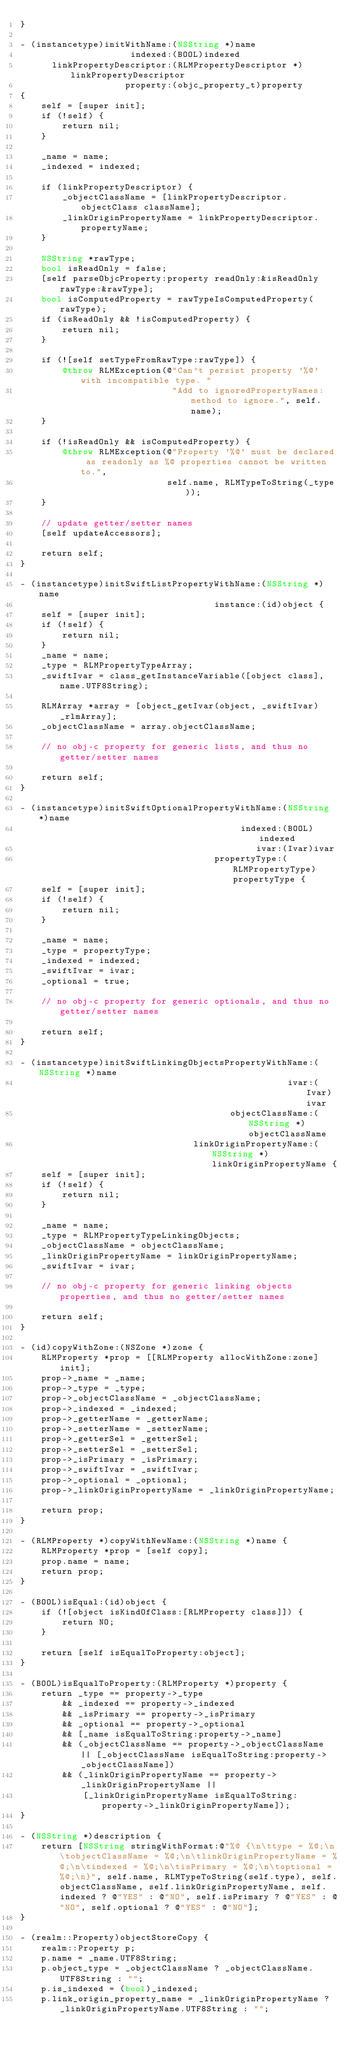Convert code to text. <code><loc_0><loc_0><loc_500><loc_500><_ObjectiveC_>}

- (instancetype)initWithName:(NSString *)name
                     indexed:(BOOL)indexed
      linkPropertyDescriptor:(RLMPropertyDescriptor *)linkPropertyDescriptor
                    property:(objc_property_t)property
{
    self = [super init];
    if (!self) {
        return nil;
    }

    _name = name;
    _indexed = indexed;

    if (linkPropertyDescriptor) {
        _objectClassName = [linkPropertyDescriptor.objectClass className];
        _linkOriginPropertyName = linkPropertyDescriptor.propertyName;
    }

    NSString *rawType;
    bool isReadOnly = false;
    [self parseObjcProperty:property readOnly:&isReadOnly rawType:&rawType];
    bool isComputedProperty = rawTypeIsComputedProperty(rawType);
    if (isReadOnly && !isComputedProperty) {
        return nil;
    }

    if (![self setTypeFromRawType:rawType]) {
        @throw RLMException(@"Can't persist property '%@' with incompatible type. "
                             "Add to ignoredPropertyNames: method to ignore.", self.name);
    }

    if (!isReadOnly && isComputedProperty) {
        @throw RLMException(@"Property '%@' must be declared as readonly as %@ properties cannot be written to.",
                            self.name, RLMTypeToString(_type));
    }

    // update getter/setter names
    [self updateAccessors];

    return self;
}

- (instancetype)initSwiftListPropertyWithName:(NSString *)name
                                     instance:(id)object {
    self = [super init];
    if (!self) {
        return nil;
    }
    _name = name;
    _type = RLMPropertyTypeArray;
    _swiftIvar = class_getInstanceVariable([object class], name.UTF8String);

    RLMArray *array = [object_getIvar(object, _swiftIvar) _rlmArray];
    _objectClassName = array.objectClassName;

    // no obj-c property for generic lists, and thus no getter/setter names

    return self;
}

- (instancetype)initSwiftOptionalPropertyWithName:(NSString *)name
                                          indexed:(BOOL)indexed
                                             ivar:(Ivar)ivar
                                     propertyType:(RLMPropertyType)propertyType {
    self = [super init];
    if (!self) {
        return nil;
    }

    _name = name;
    _type = propertyType;
    _indexed = indexed;
    _swiftIvar = ivar;
    _optional = true;

    // no obj-c property for generic optionals, and thus no getter/setter names

    return self;
}

- (instancetype)initSwiftLinkingObjectsPropertyWithName:(NSString *)name
                                                   ivar:(Ivar)ivar
                                        objectClassName:(NSString *)objectClassName
                                 linkOriginPropertyName:(NSString *)linkOriginPropertyName {
    self = [super init];
    if (!self) {
        return nil;
    }

    _name = name;
    _type = RLMPropertyTypeLinkingObjects;
    _objectClassName = objectClassName;
    _linkOriginPropertyName = linkOriginPropertyName;
    _swiftIvar = ivar;

    // no obj-c property for generic linking objects properties, and thus no getter/setter names

    return self;
}

- (id)copyWithZone:(NSZone *)zone {
    RLMProperty *prop = [[RLMProperty allocWithZone:zone] init];
    prop->_name = _name;
    prop->_type = _type;
    prop->_objectClassName = _objectClassName;
    prop->_indexed = _indexed;
    prop->_getterName = _getterName;
    prop->_setterName = _setterName;
    prop->_getterSel = _getterSel;
    prop->_setterSel = _setterSel;
    prop->_isPrimary = _isPrimary;
    prop->_swiftIvar = _swiftIvar;
    prop->_optional = _optional;
    prop->_linkOriginPropertyName = _linkOriginPropertyName;

    return prop;
}

- (RLMProperty *)copyWithNewName:(NSString *)name {
    RLMProperty *prop = [self copy];
    prop.name = name;
    return prop;
}

- (BOOL)isEqual:(id)object {
    if (![object isKindOfClass:[RLMProperty class]]) {
        return NO;
    }

    return [self isEqualToProperty:object];
}

- (BOOL)isEqualToProperty:(RLMProperty *)property {
    return _type == property->_type
        && _indexed == property->_indexed
        && _isPrimary == property->_isPrimary
        && _optional == property->_optional
        && [_name isEqualToString:property->_name]
        && (_objectClassName == property->_objectClassName  || [_objectClassName isEqualToString:property->_objectClassName])
        && (_linkOriginPropertyName == property->_linkOriginPropertyName ||
            [_linkOriginPropertyName isEqualToString:property->_linkOriginPropertyName]);
}

- (NSString *)description {
    return [NSString stringWithFormat:@"%@ {\n\ttype = %@;\n\tobjectClassName = %@;\n\tlinkOriginPropertyName = %@;\n\tindexed = %@;\n\tisPrimary = %@;\n\toptional = %@;\n}", self.name, RLMTypeToString(self.type), self.objectClassName, self.linkOriginPropertyName, self.indexed ? @"YES" : @"NO", self.isPrimary ? @"YES" : @"NO", self.optional ? @"YES" : @"NO"];
}

- (realm::Property)objectStoreCopy {
    realm::Property p;
    p.name = _name.UTF8String;
    p.object_type = _objectClassName ? _objectClassName.UTF8String : "";
    p.is_indexed = (bool)_indexed;
    p.link_origin_property_name = _linkOriginPropertyName ? _linkOriginPropertyName.UTF8String : "";</code> 